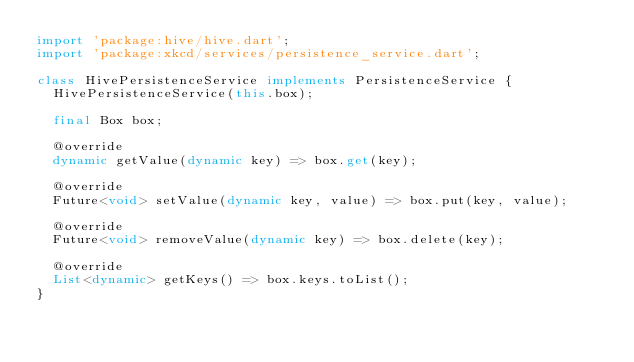Convert code to text. <code><loc_0><loc_0><loc_500><loc_500><_Dart_>import 'package:hive/hive.dart';
import 'package:xkcd/services/persistence_service.dart';

class HivePersistenceService implements PersistenceService {
  HivePersistenceService(this.box);

  final Box box;

  @override
  dynamic getValue(dynamic key) => box.get(key);

  @override
  Future<void> setValue(dynamic key, value) => box.put(key, value);

  @override
  Future<void> removeValue(dynamic key) => box.delete(key);

  @override
  List<dynamic> getKeys() => box.keys.toList();
}
</code> 